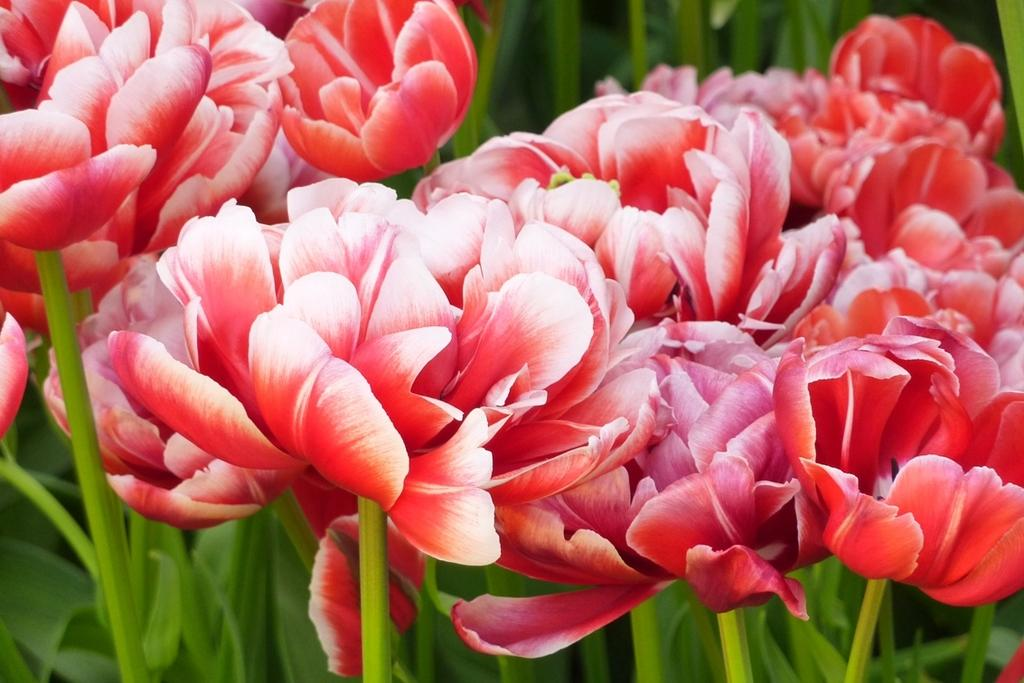What is the primary subject of the image? There are many flowers in the image. Can you describe the plants in the background of the image? There are plants visible in the background of the image. What type of feast is being prepared on the tray in the image? There is no tray or feast present in the image; it features many flowers and plants. 